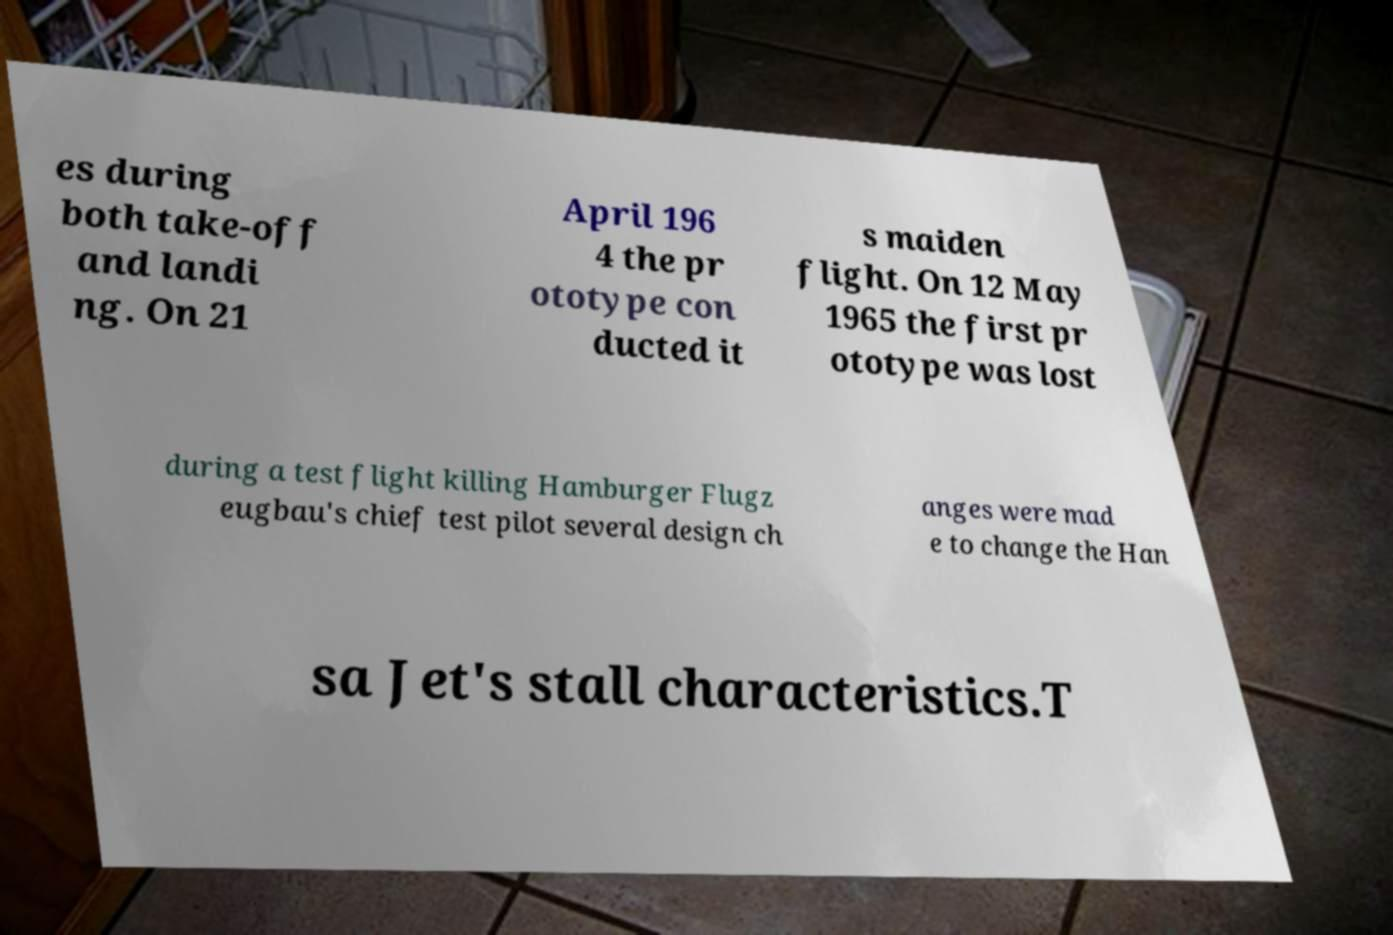Can you accurately transcribe the text from the provided image for me? es during both take-off and landi ng. On 21 April 196 4 the pr ototype con ducted it s maiden flight. On 12 May 1965 the first pr ototype was lost during a test flight killing Hamburger Flugz eugbau's chief test pilot several design ch anges were mad e to change the Han sa Jet's stall characteristics.T 